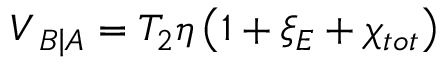<formula> <loc_0><loc_0><loc_500><loc_500>{ { V } _ { B \right | A } } = { { T } _ { 2 } } \eta \left ( 1 + { { \xi } _ { E } } + { { \chi } _ { t o t } } \right )</formula> 